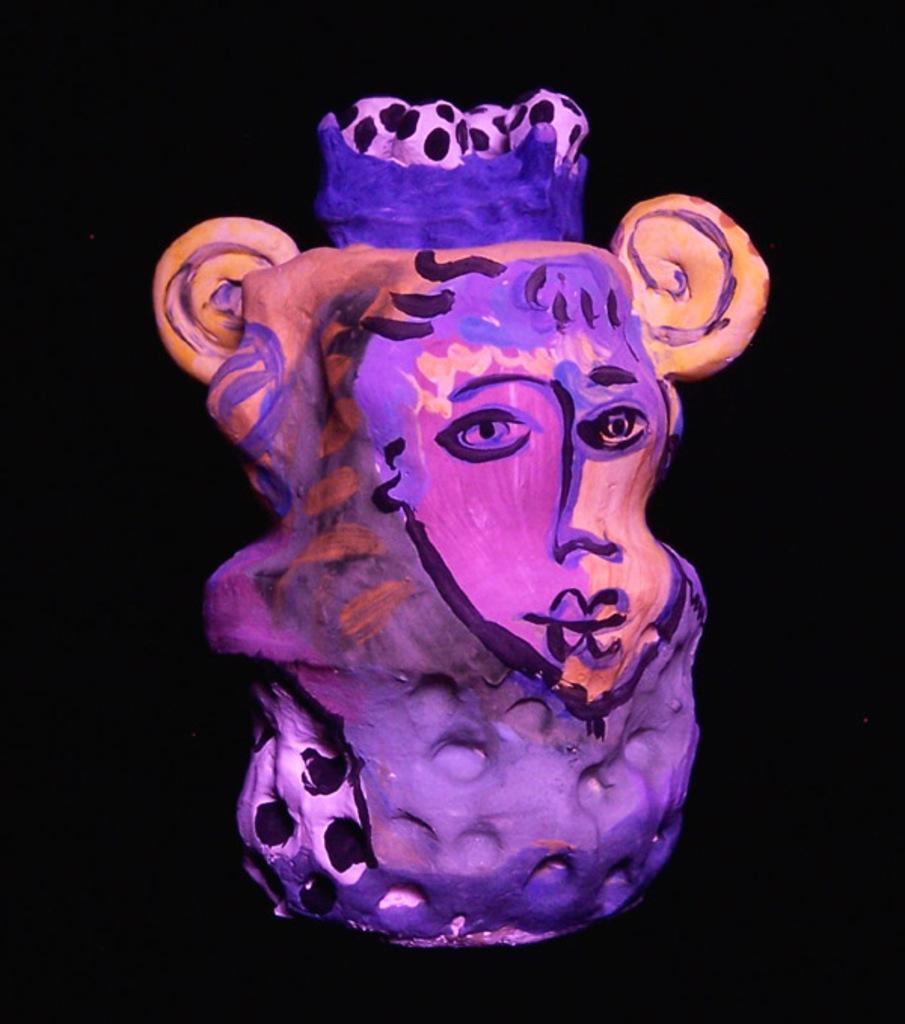Describe this image in one or two sentences. There is a painting in different colors and the background is dark in color. 